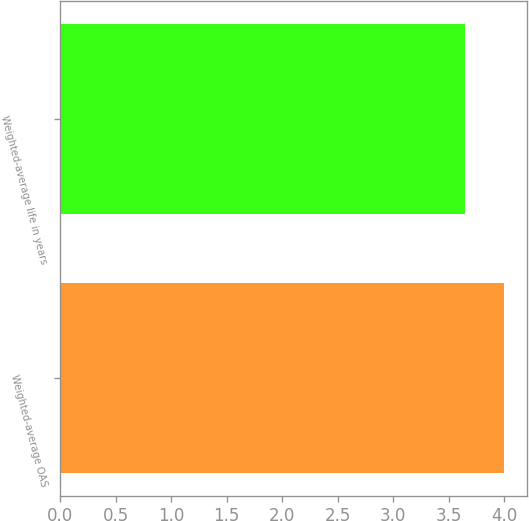Convert chart. <chart><loc_0><loc_0><loc_500><loc_500><bar_chart><fcel>Weighted-average OAS<fcel>Weighted-average life in years<nl><fcel>4<fcel>3.65<nl></chart> 